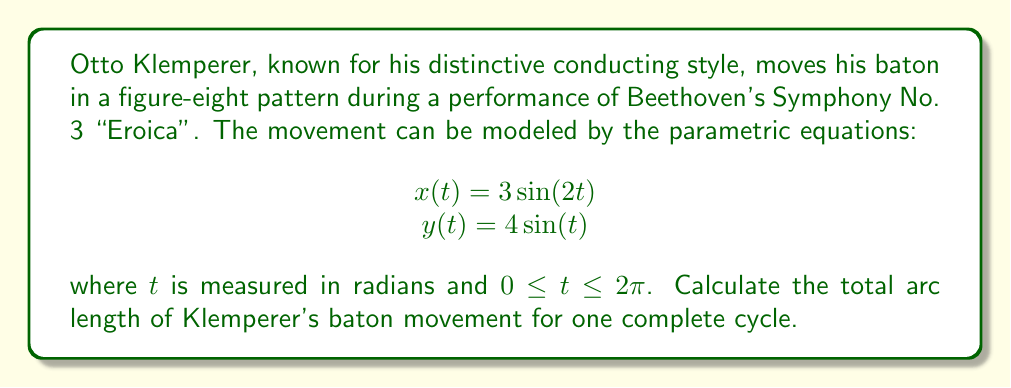Can you solve this math problem? To calculate the arc length of a curve defined by parametric equations, we use the formula:

$$ L = \int_{a}^{b} \sqrt{\left(\frac{dx}{dt}\right)^2 + \left(\frac{dy}{dt}\right)^2} dt $$

Where $a$ and $b$ are the start and end values of the parameter $t$.

Step 1: Find $\frac{dx}{dt}$ and $\frac{dy}{dt}$
$\frac{dx}{dt} = 6\cos(2t)$
$\frac{dy}{dt} = 4\cos(t)$

Step 2: Substitute these into the arc length formula
$$ L = \int_{0}^{2\pi} \sqrt{(6\cos(2t))^2 + (4\cos(t))^2} dt $$

Step 3: Simplify the expression under the square root
$$ L = \int_{0}^{2\pi} \sqrt{36\cos^2(2t) + 16\cos^2(t)} dt $$

Step 4: This integral cannot be solved analytically, so we need to use numerical integration methods. Using a computer algebra system or numerical integration tool, we can evaluate this integral.

Step 5: After numerical integration, we find that the value of the integral is approximately 22.1016.
Answer: The total arc length of Otto Klemperer's baton movement for one complete cycle is approximately 22.1016 units. 